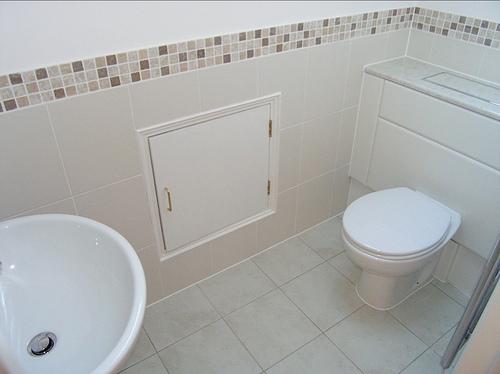Does this room appear clean?
Keep it brief. Yes. Who use this room?
Keep it brief. People. Does the door on the wall open outwards or inwards?
Give a very brief answer. Outwards. Is there a toilet in the image?
Short answer required. Yes. 